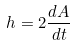<formula> <loc_0><loc_0><loc_500><loc_500>h = 2 \frac { d A } { d t }</formula> 